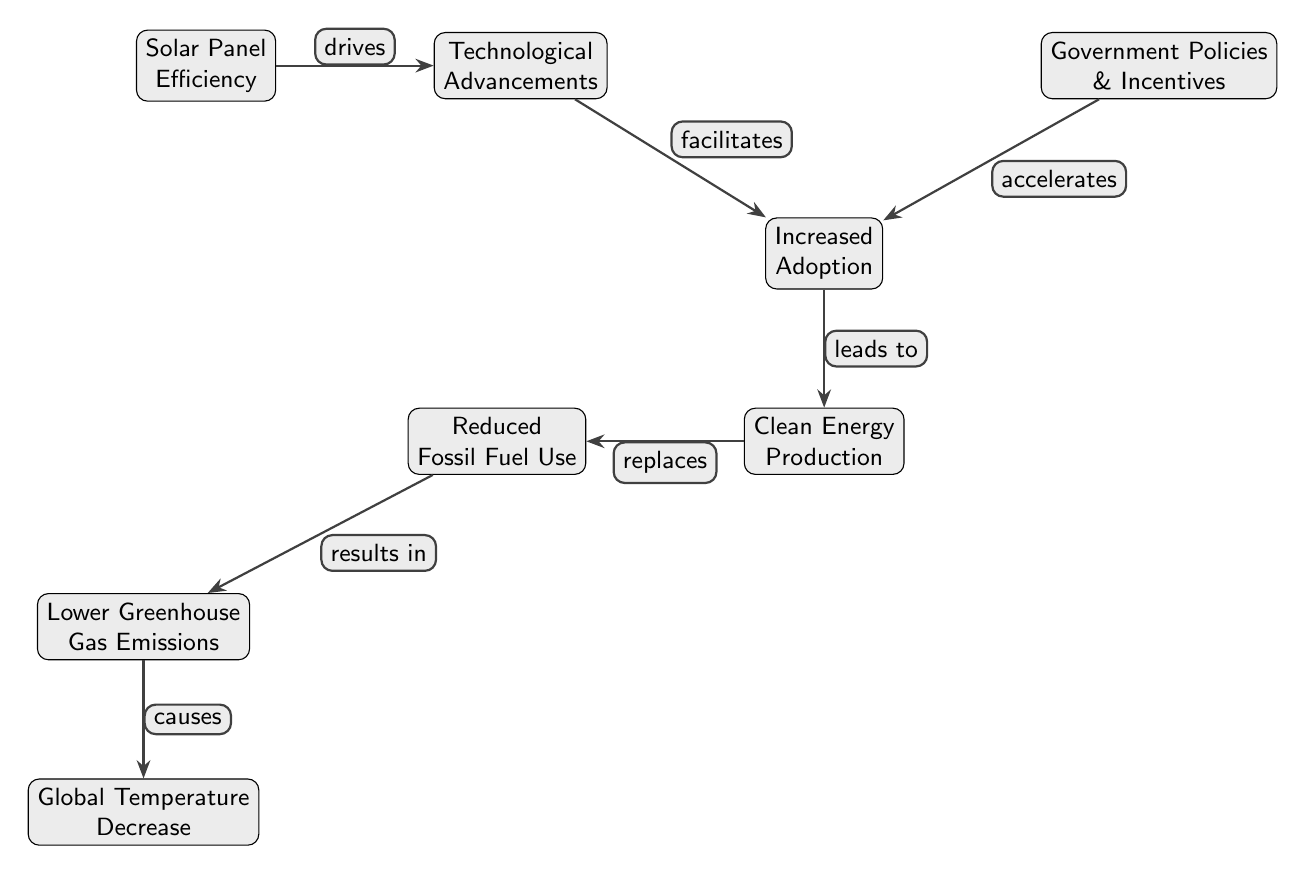What drives technological advancements in solar panels? The diagram shows that solar panel efficiency drives technological advancements. This is indicated by the arrow from the "Solar Panel Efficiency" node pointing to the "Technological Advancements" node labeled "drives."
Answer: solar panel efficiency How many nodes are in the diagram? By counting the distinct boxes (nodes), we see there are 7 nodes, which include: Solar Panel Efficiency, Technological Advancements, Increased Adoption, Clean Energy Production, Reduced Fossil Fuel Use, Lower Greenhouse Gas Emissions, and Global Temperature Decrease.
Answer: 7 Which element accelerates increased adoption? The diagram indicates that government policies and incentives accelerate increased adoption, as shown by the arrow from the "Government Policies & Incentives" node pointing towards the "Increased Adoption" node with the label "accelerates."
Answer: government policies & incentives What results in lower greenhouse gas emissions? According to the diagram, reduced fossil fuel use results in lower greenhouse gas emissions, as shown by the arrow leading from the "Reduced Fossil Fuel Use" node to the "Lower Greenhouse Gas Emissions" node with the label "results in."
Answer: reduced fossil fuel use How does increased adoption affect clean energy production? The diagram indicates that increased adoption leads to clean energy production. This is represented by the arrow from the "Increased Adoption" node to the "Clean Energy Production" node, marked with the label "leads to."
Answer: leads to What is the final outcome indicated in the diagram? The final outcome indicated by the flow of the diagram is global temperature decrease, as shown at the bottom node which is the last in the process leading from lower greenhouse gas emissions.
Answer: global temperature decrease Which relationship mediates between solar efficiency and global temperature decrease? The relationship mediated through multiple nodes shows that solar panel efficiency drives technological advancements, which facilitates increased adoption, leading to clean energy production, which replaces reduced fossil fuel use, resulting in lower greenhouse gas emissions, and finally causing global temperature decrease.
Answer: numerous relationships through nodes 